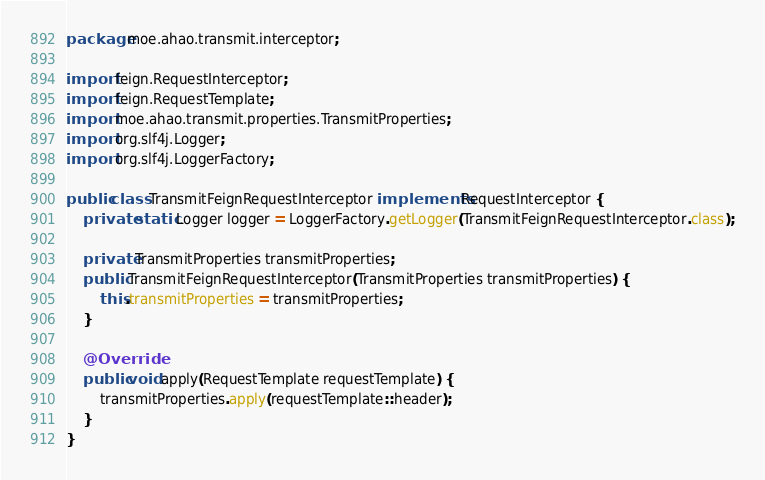Convert code to text. <code><loc_0><loc_0><loc_500><loc_500><_Java_>package moe.ahao.transmit.interceptor;

import feign.RequestInterceptor;
import feign.RequestTemplate;
import moe.ahao.transmit.properties.TransmitProperties;
import org.slf4j.Logger;
import org.slf4j.LoggerFactory;

public class TransmitFeignRequestInterceptor implements RequestInterceptor {
    private static Logger logger = LoggerFactory.getLogger(TransmitFeignRequestInterceptor.class);

    private TransmitProperties transmitProperties;
    public TransmitFeignRequestInterceptor(TransmitProperties transmitProperties) {
        this.transmitProperties = transmitProperties;
    }

    @Override
    public void apply(RequestTemplate requestTemplate) {
        transmitProperties.apply(requestTemplate::header);
    }
}
</code> 